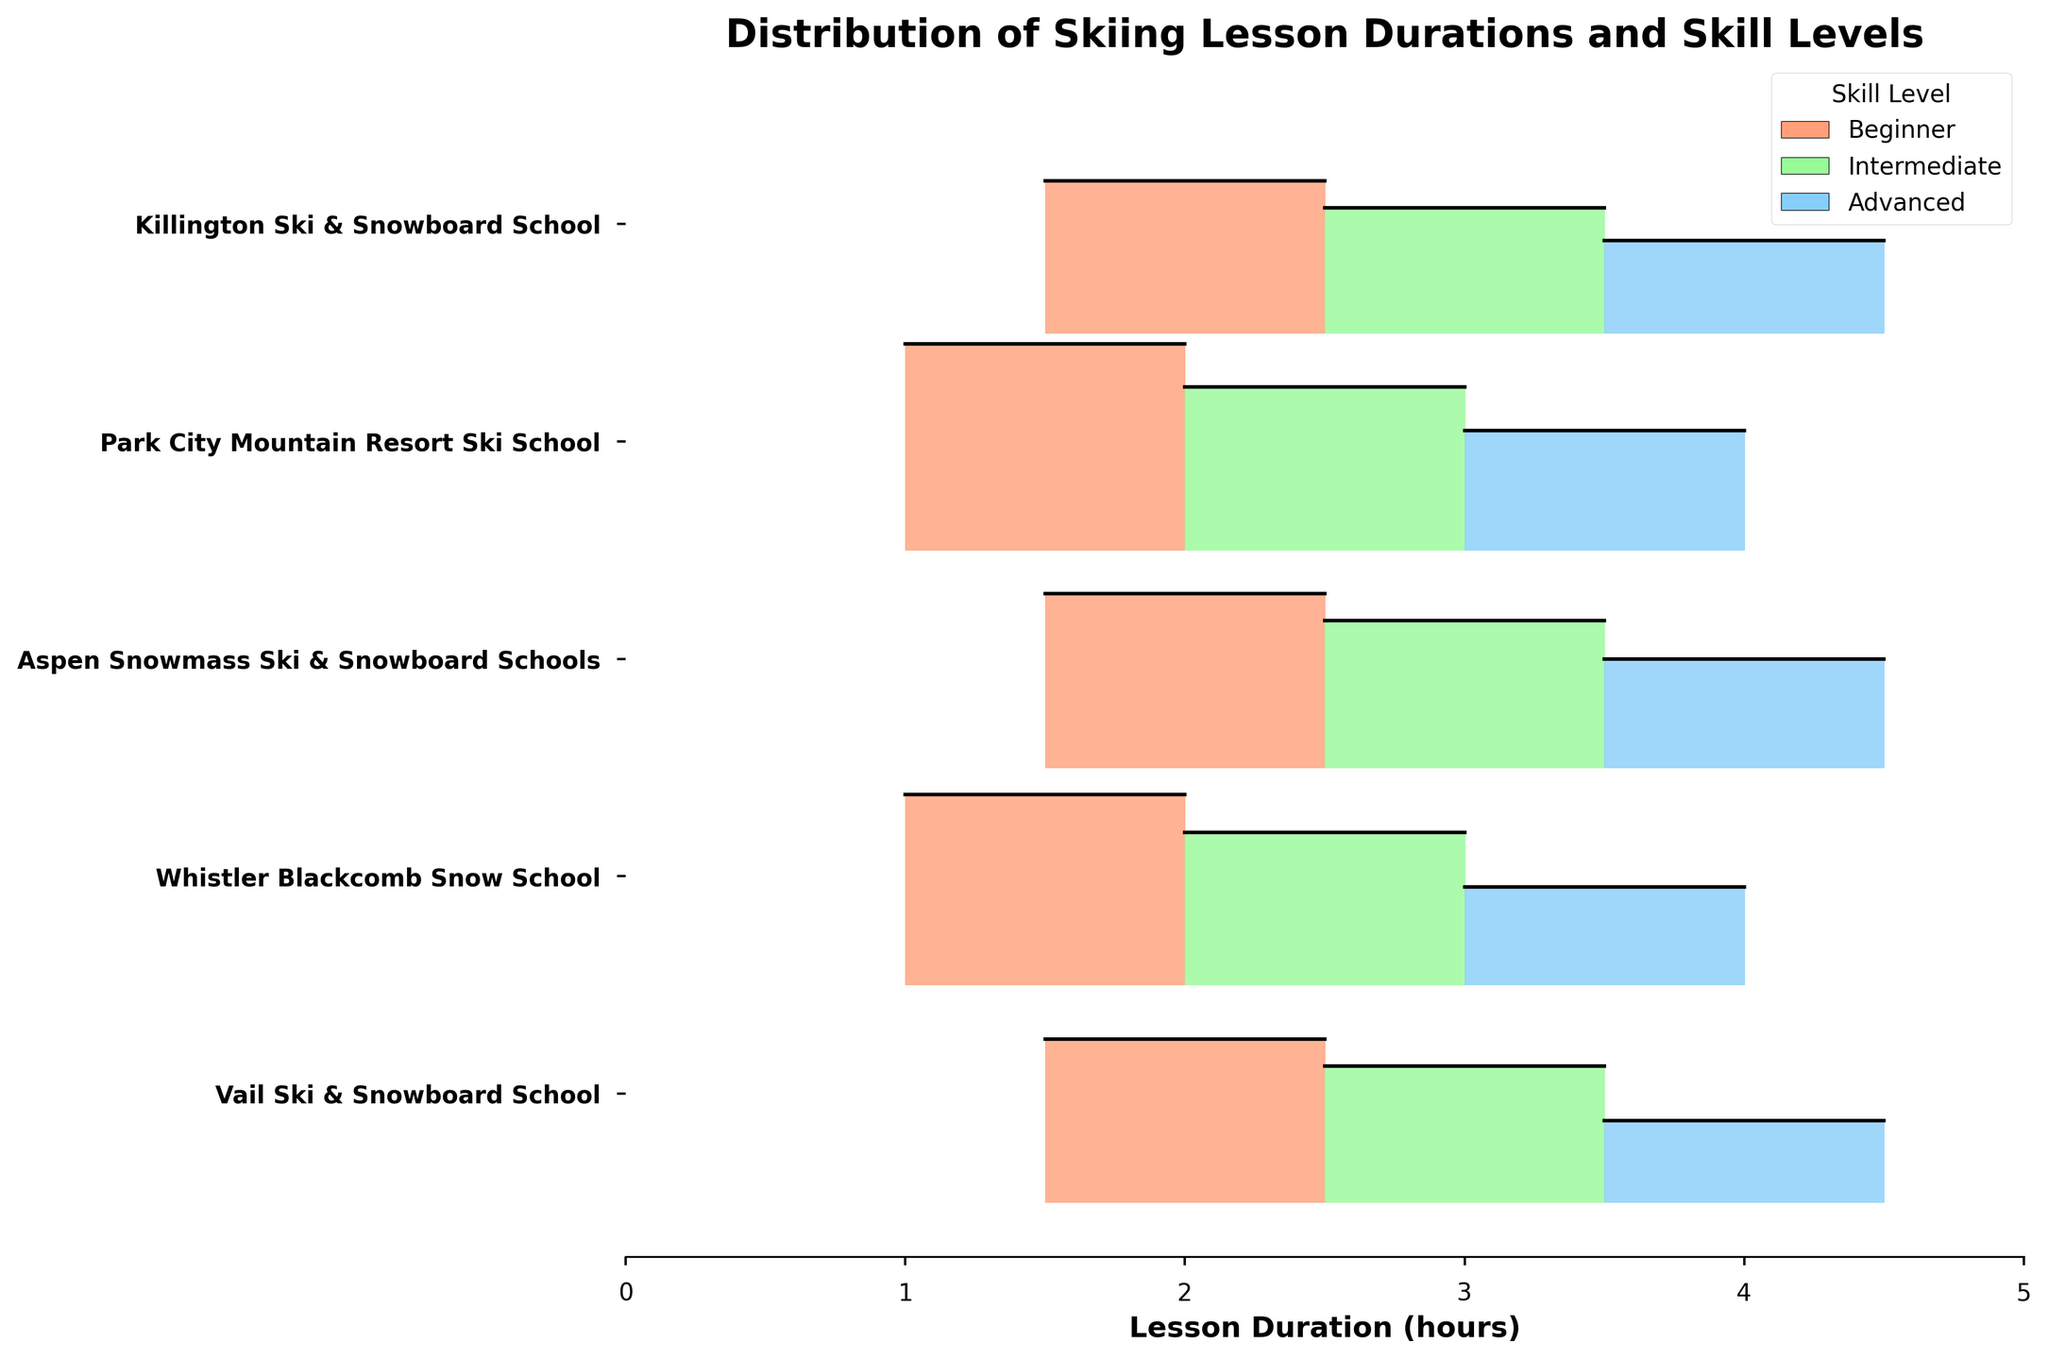What's the title of the figure? The title is written at the top of the figure and typically summarizes the content of the plot.
Answer: Distribution of Skiing Lesson Durations and Skill Levels What is the x-axis label in this figure? The x-axis label is usually written below the x-axis and indicates the variable being measured along the x-axis.
Answer: Lesson Duration (hours) Which ski school offers the highest frequency of beginner lessons? To answer this, look for the tallest filled area at the base level for beginners among all ski schools.
Answer: Park City Mountain Resort Ski School What are the skill levels represented in this figure, and how are they indicated? Observe the legend in the figure that shows the various colors corresponding to different skill levels.
Answer: Beginner, Intermediate, Advanced (indicated by different colors) Which ski school has the longest lesson duration for advanced skiers? Identify the filled area for advanced skiers and check the corresponding x-axis values across all ski schools.
Answer: Vail Ski & Snowboard School, Aspen Snowmass Ski & Snowboard Schools, and Killington Ski & Snowboard School (all offer 4-hour lessons) How many total intermediate lessons are offered by Aspen Snowmass Ski & Snowboard Schools based on frequency? Locate the filled area for intermediate lessons of Aspen Snowmass Ski & Snowboard Schools and refer to its frequency value.
Answer: 27 What is the combined frequency of beginner lessons across all ski schools? Sum the frequency values of beginner lessons from each ski school.
Answer: 30 (Vail) + 35 (Whistler) + 32 (Aspen) + 38 (Park City) + 28 (Killington) = 163 Which skill level at Whistler Blackcomb Snow School has the least frequency, and what is its value? Check the frequencies of the three skill levels at Whistler Blackcomb Snow School and identify the smallest one.
Answer: Advanced, 18 Compare the lesson durations for intermediate skiers at Vail Ski & Snowboard School and Whistler Blackcomb Snow School. Which one is longer? Look at the x-axis values for intermediate lessons at both Vail Ski & Snowboard School and Whistler Blackcomb Snow School.
Answer: Vail Ski & Snowboard School (3 hours) Do all ski schools offer beginner lessons of the same duration? Check the x-axis values for beginner lessons across all ski schools and see if they match.
Answer: No 